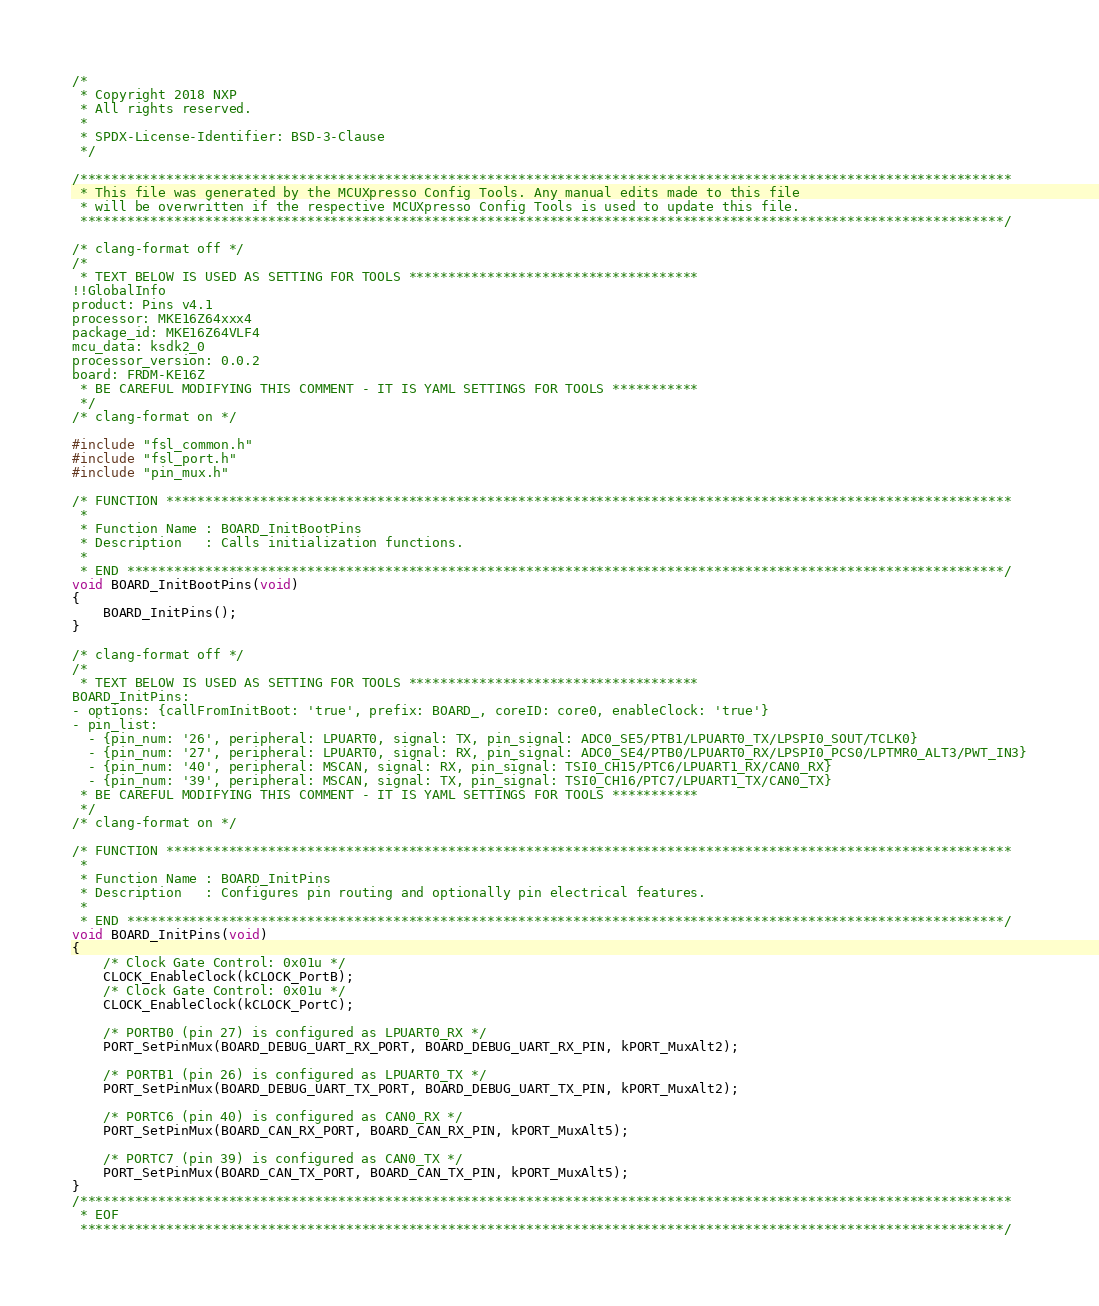<code> <loc_0><loc_0><loc_500><loc_500><_C_>/*
 * Copyright 2018 NXP
 * All rights reserved.
 *
 * SPDX-License-Identifier: BSD-3-Clause
 */

/***********************************************************************************************************************
 * This file was generated by the MCUXpresso Config Tools. Any manual edits made to this file
 * will be overwritten if the respective MCUXpresso Config Tools is used to update this file.
 **********************************************************************************************************************/

/* clang-format off */
/*
 * TEXT BELOW IS USED AS SETTING FOR TOOLS *************************************
!!GlobalInfo
product: Pins v4.1
processor: MKE16Z64xxx4
package_id: MKE16Z64VLF4
mcu_data: ksdk2_0
processor_version: 0.0.2
board: FRDM-KE16Z
 * BE CAREFUL MODIFYING THIS COMMENT - IT IS YAML SETTINGS FOR TOOLS ***********
 */
/* clang-format on */

#include "fsl_common.h"
#include "fsl_port.h"
#include "pin_mux.h"

/* FUNCTION ************************************************************************************************************
 *
 * Function Name : BOARD_InitBootPins
 * Description   : Calls initialization functions.
 *
 * END ****************************************************************************************************************/
void BOARD_InitBootPins(void)
{
    BOARD_InitPins();
}

/* clang-format off */
/*
 * TEXT BELOW IS USED AS SETTING FOR TOOLS *************************************
BOARD_InitPins:
- options: {callFromInitBoot: 'true', prefix: BOARD_, coreID: core0, enableClock: 'true'}
- pin_list:
  - {pin_num: '26', peripheral: LPUART0, signal: TX, pin_signal: ADC0_SE5/PTB1/LPUART0_TX/LPSPI0_SOUT/TCLK0}
  - {pin_num: '27', peripheral: LPUART0, signal: RX, pin_signal: ADC0_SE4/PTB0/LPUART0_RX/LPSPI0_PCS0/LPTMR0_ALT3/PWT_IN3}
  - {pin_num: '40', peripheral: MSCAN, signal: RX, pin_signal: TSI0_CH15/PTC6/LPUART1_RX/CAN0_RX}
  - {pin_num: '39', peripheral: MSCAN, signal: TX, pin_signal: TSI0_CH16/PTC7/LPUART1_TX/CAN0_TX}
 * BE CAREFUL MODIFYING THIS COMMENT - IT IS YAML SETTINGS FOR TOOLS ***********
 */
/* clang-format on */

/* FUNCTION ************************************************************************************************************
 *
 * Function Name : BOARD_InitPins
 * Description   : Configures pin routing and optionally pin electrical features.
 *
 * END ****************************************************************************************************************/
void BOARD_InitPins(void)
{
    /* Clock Gate Control: 0x01u */
    CLOCK_EnableClock(kCLOCK_PortB);
    /* Clock Gate Control: 0x01u */
    CLOCK_EnableClock(kCLOCK_PortC);

    /* PORTB0 (pin 27) is configured as LPUART0_RX */
    PORT_SetPinMux(BOARD_DEBUG_UART_RX_PORT, BOARD_DEBUG_UART_RX_PIN, kPORT_MuxAlt2);

    /* PORTB1 (pin 26) is configured as LPUART0_TX */
    PORT_SetPinMux(BOARD_DEBUG_UART_TX_PORT, BOARD_DEBUG_UART_TX_PIN, kPORT_MuxAlt2);

    /* PORTC6 (pin 40) is configured as CAN0_RX */
    PORT_SetPinMux(BOARD_CAN_RX_PORT, BOARD_CAN_RX_PIN, kPORT_MuxAlt5);

    /* PORTC7 (pin 39) is configured as CAN0_TX */
    PORT_SetPinMux(BOARD_CAN_TX_PORT, BOARD_CAN_TX_PIN, kPORT_MuxAlt5);
}
/***********************************************************************************************************************
 * EOF
 **********************************************************************************************************************/
</code> 